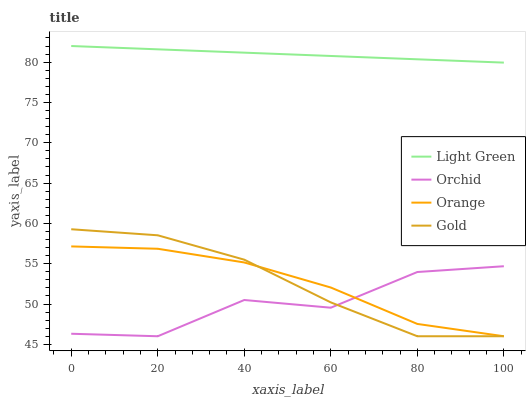Does Gold have the minimum area under the curve?
Answer yes or no. No. Does Gold have the maximum area under the curve?
Answer yes or no. No. Is Gold the smoothest?
Answer yes or no. No. Is Gold the roughest?
Answer yes or no. No. Does Light Green have the lowest value?
Answer yes or no. No. Does Gold have the highest value?
Answer yes or no. No. Is Orange less than Light Green?
Answer yes or no. Yes. Is Light Green greater than Orange?
Answer yes or no. Yes. Does Orange intersect Light Green?
Answer yes or no. No. 